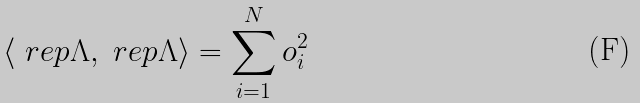Convert formula to latex. <formula><loc_0><loc_0><loc_500><loc_500>\langle \ r e p { \Lambda } , \ r e p { \Lambda } \rangle = \sum _ { i = 1 } ^ { N } o _ { i } ^ { 2 }</formula> 